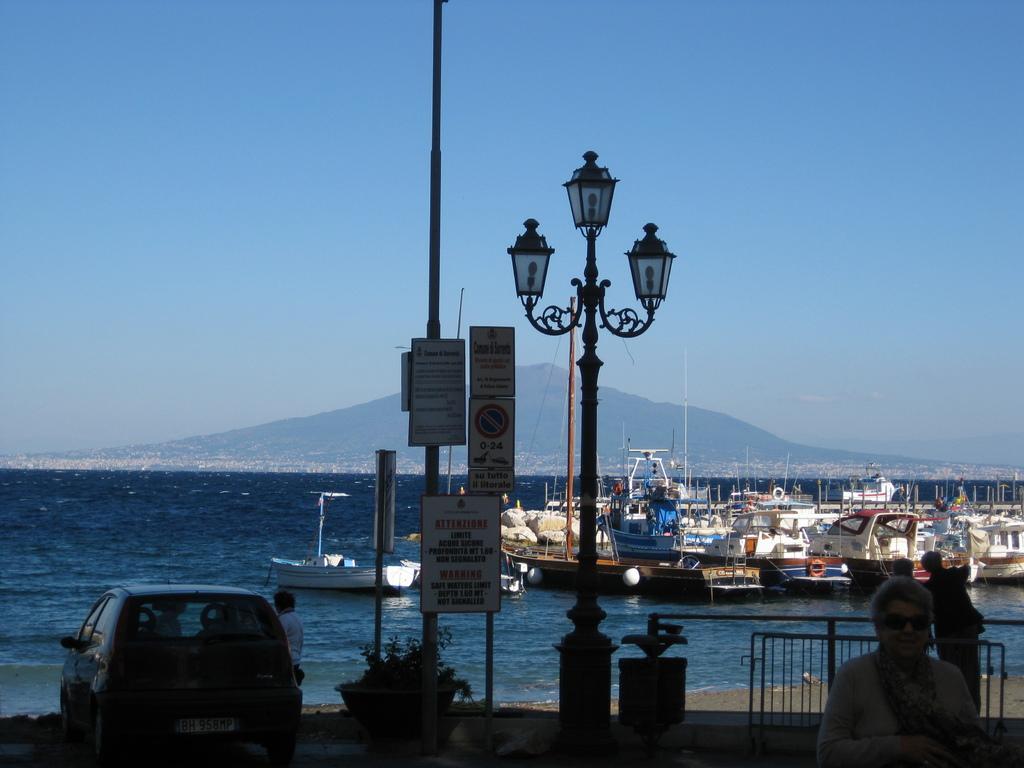How would you summarize this image in a sentence or two? In the bottom left side of the image there is a vehicle and plant. In the middle of the image there are some poles and sign boards and lights. Behind the poles there is fencing. Behind the fencing there is water, above the water there are some ships and boats. At the top of the image there is sky. In the bottom right corner of the image few people are standing. 